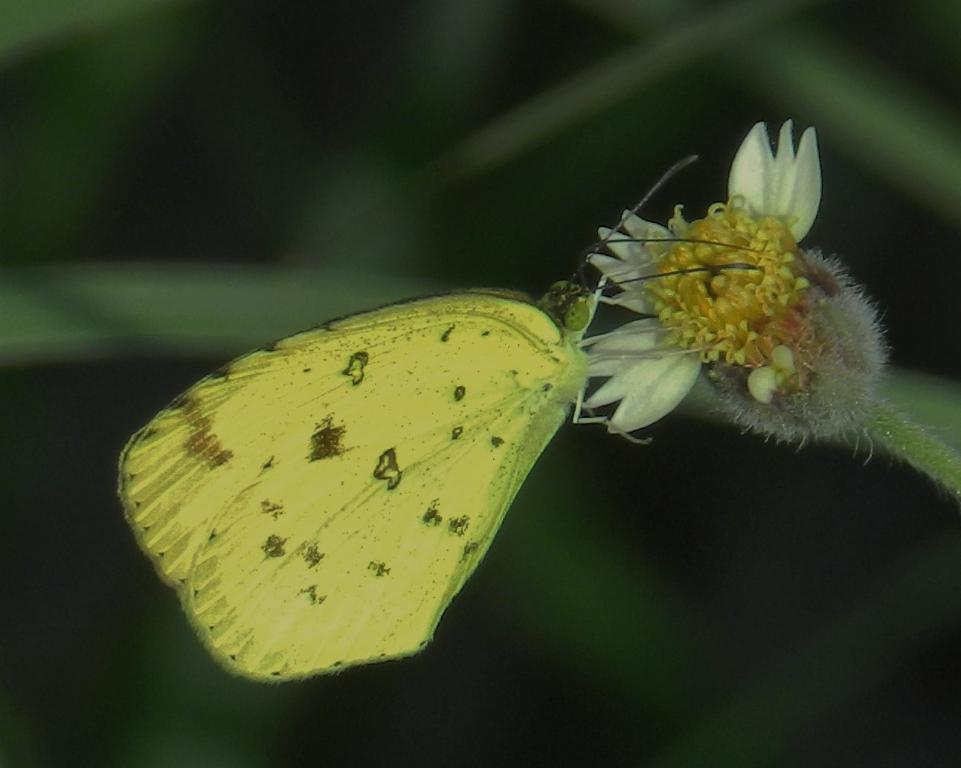Please provide a concise description of this image. In this image I can see the butterfly and the butterfly is in yellow color. The butterfly is on the flower and the flower is in yellow and white color and I can see blurred background. 